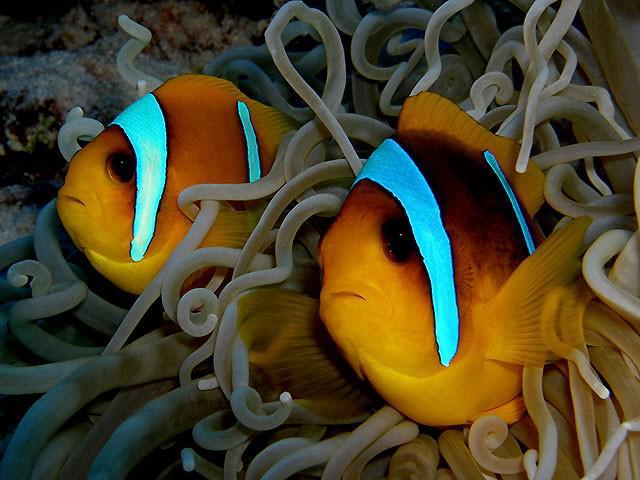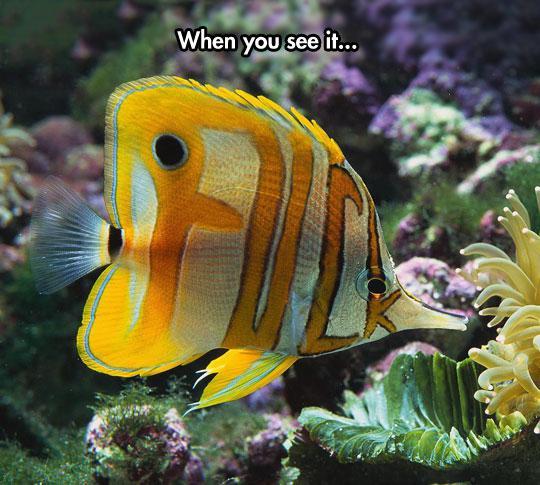The first image is the image on the left, the second image is the image on the right. Assess this claim about the two images: "There are various species of fish in one of the images.". Correct or not? Answer yes or no. No. 